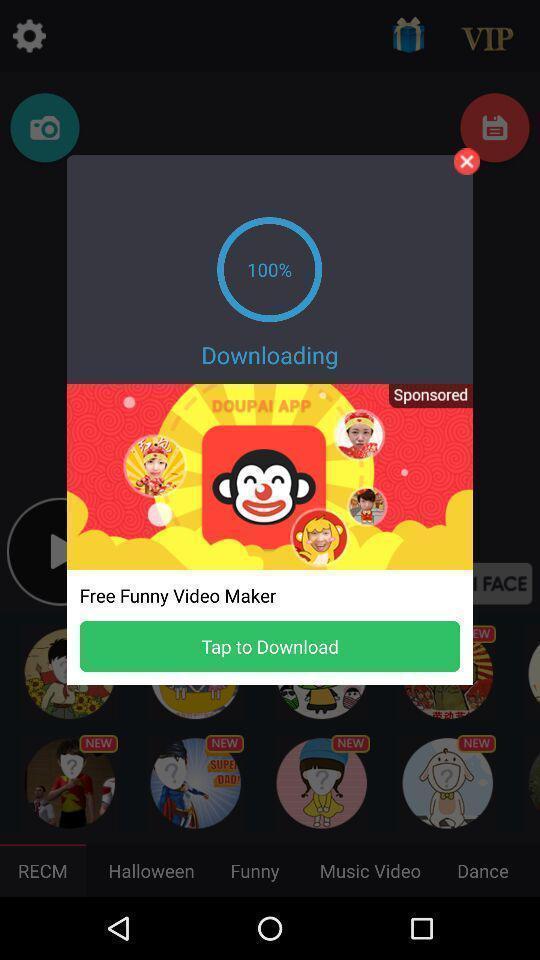Describe the content in this image. Pop-up showing download status. 